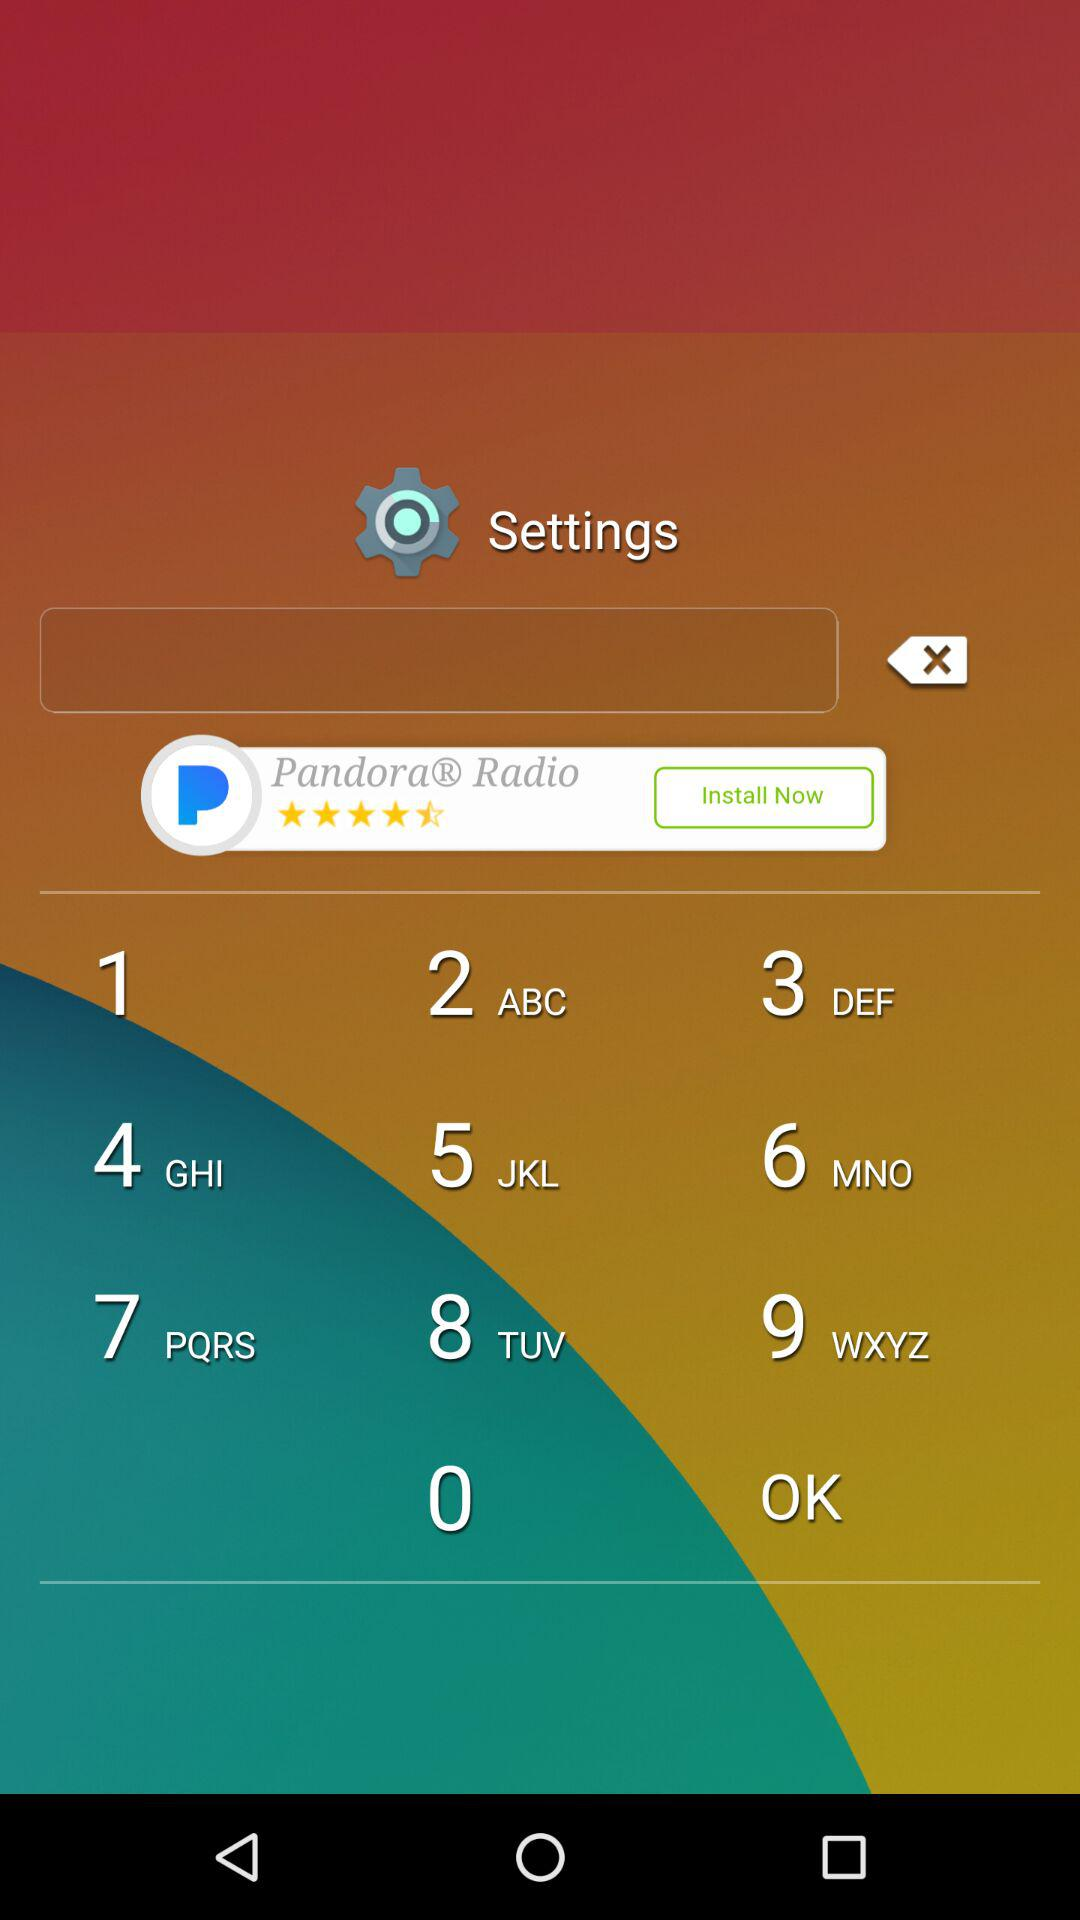How many more downloads does TouchPal Keyboard have than reviews?
Answer the question using a single word or phrase. 69 million 